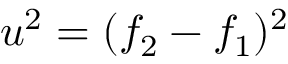<formula> <loc_0><loc_0><loc_500><loc_500>u ^ { 2 } = ( f _ { 2 } - f _ { 1 } ) ^ { 2 }</formula> 